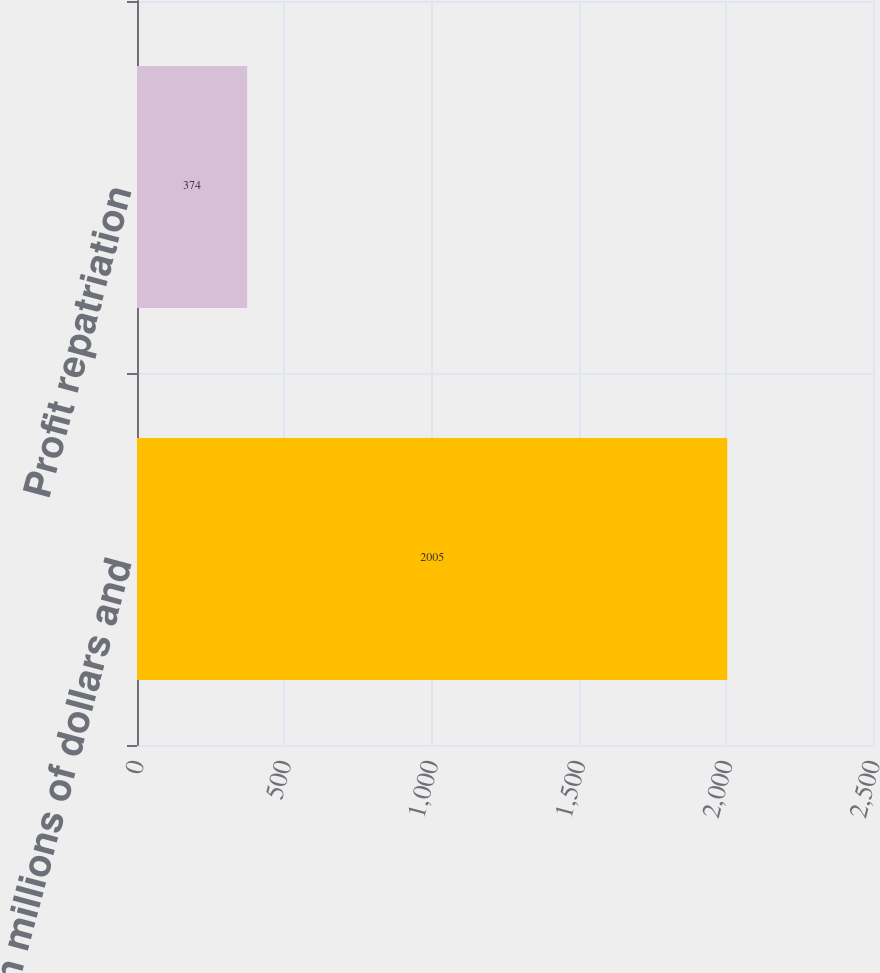Convert chart. <chart><loc_0><loc_0><loc_500><loc_500><bar_chart><fcel>(In millions of dollars and<fcel>Profit repatriation<nl><fcel>2005<fcel>374<nl></chart> 